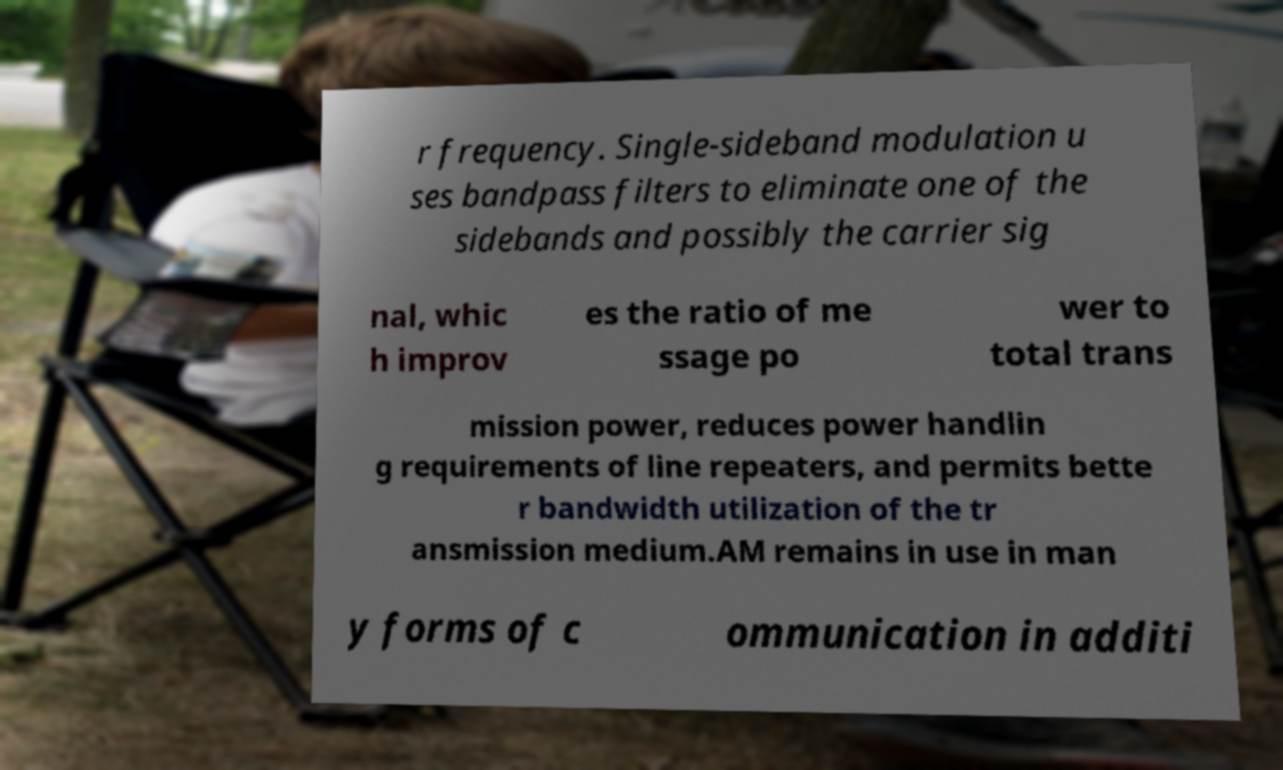Could you extract and type out the text from this image? r frequency. Single-sideband modulation u ses bandpass filters to eliminate one of the sidebands and possibly the carrier sig nal, whic h improv es the ratio of me ssage po wer to total trans mission power, reduces power handlin g requirements of line repeaters, and permits bette r bandwidth utilization of the tr ansmission medium.AM remains in use in man y forms of c ommunication in additi 